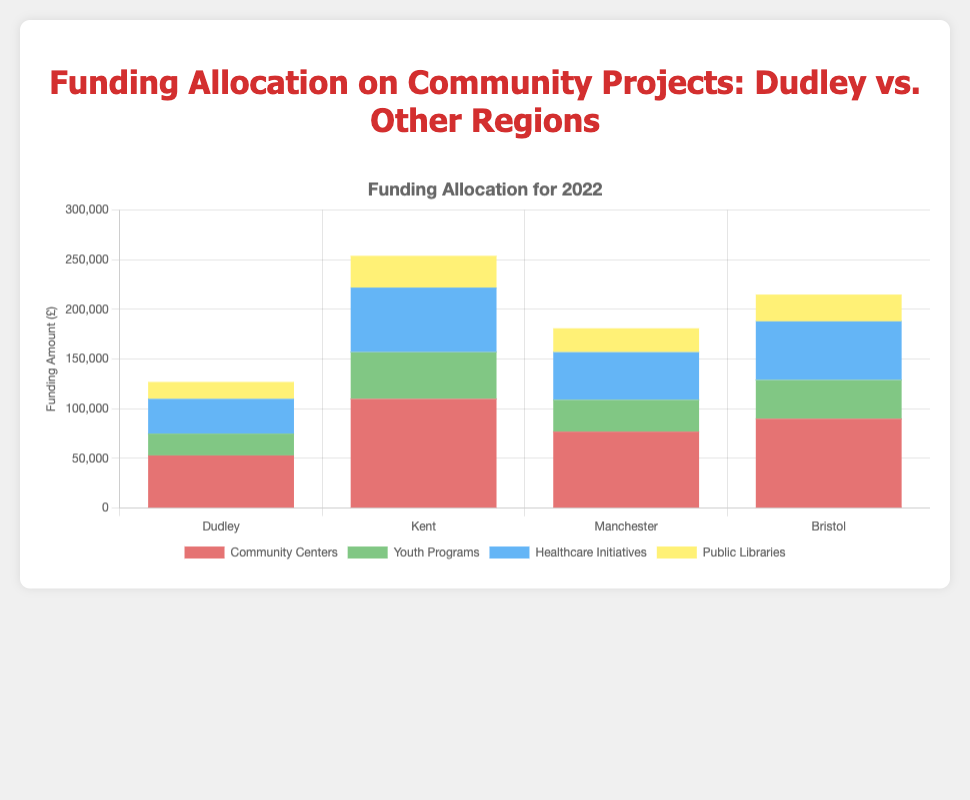Which region allocated the most funding to Public Libraries in 2022? Bristol allocated the highest funding to Public Libraries in 2022, with £27,000 as seen by the tallest light yellow bar in that segment.
Answer: Bristol How much more funding did Kent allocate to Community Centers compared to Dudley in 2022? Kent allocated £110,000 and Dudley allocated £53,000 to Community Centers in 2022. The difference is £110,000 - £53,000 = £57,000.
Answer: £57,000 What is the total funding allocated by Manchester across all projects in 2022? By summing up Manchester's allocations: Community Centers (£77,000) + Youth Programs (£32,000) + Healthcare Initiatives (£48,000) + Public Libraries (£24,000) = £77,000 + £32,000 + £48,000 + £24,000 = £181,000.
Answer: £181,000 Which project category received the least funding in Dudley in 2022? Youth Programs in Dudley received the least funding of £22,000, which is the shortest segment (green bar) in Dudley's total funding bar.
Answer: Youth Programs Did the sum of Healthcare Initiatives funding in Kent exceed the total funding for all projects in Dudley in 2022? Healthcare Initiatives funding in Kent was £65,000. Total funding in Dudley (adding all projects' funding): £53,000 (Community Centers) + £22,000 (Youth Programs) + £35,000 (Healthcare Initiatives) + £17,000 (Public Libraries) = £53,000 + £22,000 + £35,000 + £17,000 = £127,000. £65,000 (Healthcare Initiatives in Kent) is less than £127,000 (total in Dudley).
Answer: No Which region allocated the second highest total funding across all project categories in 2022? First, find the total funding for each region in 2022: Kent: £110,000 + £47,000 + £65,000 + £32,000 = £254,000; Manchester: £181,000; Bristol: £90000 + £39000 + £59000 + £27000 = £215000; Dudley: £127,000. Bristol has the second highest total at £215,000.
Answer: Bristol What is the difference in funding allocation for Youth Programs between Manchester and Bristol in 2022? Bristol allocated £39,000 and Manchester allocated £32,000 to Youth Programs in 2022. The difference is £39,000 - £32,000 = £7,000.
Answer: £7,000 What percentage of Dudley’s total funding in 2022 was allocated to Healthcare Initiatives? Total funding for Dudley in 2022 is £127,000. Funding for Healthcare Initiatives was £35,000. Percentage = (£35,000 / £127,000) * 100 ≈ 27.56%.
Answer: 27.56% 